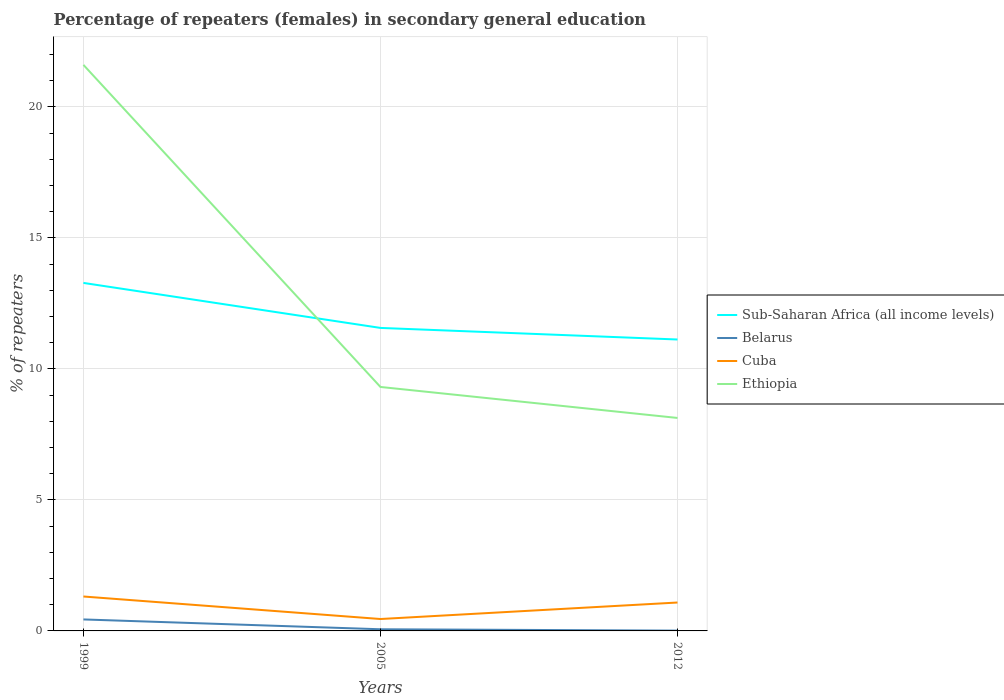How many different coloured lines are there?
Keep it short and to the point. 4. Does the line corresponding to Cuba intersect with the line corresponding to Belarus?
Provide a succinct answer. No. Across all years, what is the maximum percentage of female repeaters in Cuba?
Your answer should be very brief. 0.45. What is the total percentage of female repeaters in Belarus in the graph?
Keep it short and to the point. 0.43. What is the difference between the highest and the second highest percentage of female repeaters in Sub-Saharan Africa (all income levels)?
Provide a short and direct response. 2.16. How many lines are there?
Your response must be concise. 4. How many years are there in the graph?
Provide a short and direct response. 3. Are the values on the major ticks of Y-axis written in scientific E-notation?
Provide a short and direct response. No. Does the graph contain any zero values?
Give a very brief answer. No. Does the graph contain grids?
Give a very brief answer. Yes. Where does the legend appear in the graph?
Provide a short and direct response. Center right. What is the title of the graph?
Offer a terse response. Percentage of repeaters (females) in secondary general education. Does "Cambodia" appear as one of the legend labels in the graph?
Provide a succinct answer. No. What is the label or title of the X-axis?
Provide a succinct answer. Years. What is the label or title of the Y-axis?
Offer a very short reply. % of repeaters. What is the % of repeaters of Sub-Saharan Africa (all income levels) in 1999?
Your answer should be compact. 13.28. What is the % of repeaters of Belarus in 1999?
Offer a very short reply. 0.44. What is the % of repeaters of Cuba in 1999?
Provide a short and direct response. 1.31. What is the % of repeaters of Ethiopia in 1999?
Your answer should be very brief. 21.6. What is the % of repeaters in Sub-Saharan Africa (all income levels) in 2005?
Provide a short and direct response. 11.56. What is the % of repeaters in Belarus in 2005?
Provide a short and direct response. 0.06. What is the % of repeaters in Cuba in 2005?
Provide a succinct answer. 0.45. What is the % of repeaters in Ethiopia in 2005?
Your response must be concise. 9.31. What is the % of repeaters of Sub-Saharan Africa (all income levels) in 2012?
Your answer should be very brief. 11.12. What is the % of repeaters in Belarus in 2012?
Provide a succinct answer. 0.01. What is the % of repeaters of Cuba in 2012?
Provide a short and direct response. 1.08. What is the % of repeaters of Ethiopia in 2012?
Offer a terse response. 8.13. Across all years, what is the maximum % of repeaters in Sub-Saharan Africa (all income levels)?
Keep it short and to the point. 13.28. Across all years, what is the maximum % of repeaters in Belarus?
Make the answer very short. 0.44. Across all years, what is the maximum % of repeaters in Cuba?
Ensure brevity in your answer.  1.31. Across all years, what is the maximum % of repeaters of Ethiopia?
Ensure brevity in your answer.  21.6. Across all years, what is the minimum % of repeaters of Sub-Saharan Africa (all income levels)?
Provide a short and direct response. 11.12. Across all years, what is the minimum % of repeaters in Belarus?
Your answer should be very brief. 0.01. Across all years, what is the minimum % of repeaters of Cuba?
Give a very brief answer. 0.45. Across all years, what is the minimum % of repeaters of Ethiopia?
Give a very brief answer. 8.13. What is the total % of repeaters in Sub-Saharan Africa (all income levels) in the graph?
Keep it short and to the point. 35.96. What is the total % of repeaters of Belarus in the graph?
Provide a succinct answer. 0.51. What is the total % of repeaters in Cuba in the graph?
Provide a short and direct response. 2.85. What is the total % of repeaters of Ethiopia in the graph?
Offer a terse response. 39.04. What is the difference between the % of repeaters in Sub-Saharan Africa (all income levels) in 1999 and that in 2005?
Your answer should be compact. 1.72. What is the difference between the % of repeaters of Belarus in 1999 and that in 2005?
Offer a terse response. 0.37. What is the difference between the % of repeaters in Cuba in 1999 and that in 2005?
Your answer should be very brief. 0.86. What is the difference between the % of repeaters of Ethiopia in 1999 and that in 2005?
Your answer should be very brief. 12.29. What is the difference between the % of repeaters in Sub-Saharan Africa (all income levels) in 1999 and that in 2012?
Offer a terse response. 2.16. What is the difference between the % of repeaters of Belarus in 1999 and that in 2012?
Give a very brief answer. 0.43. What is the difference between the % of repeaters of Cuba in 1999 and that in 2012?
Your response must be concise. 0.23. What is the difference between the % of repeaters in Ethiopia in 1999 and that in 2012?
Your response must be concise. 13.47. What is the difference between the % of repeaters of Sub-Saharan Africa (all income levels) in 2005 and that in 2012?
Offer a terse response. 0.44. What is the difference between the % of repeaters in Belarus in 2005 and that in 2012?
Provide a succinct answer. 0.05. What is the difference between the % of repeaters in Cuba in 2005 and that in 2012?
Provide a succinct answer. -0.63. What is the difference between the % of repeaters in Ethiopia in 2005 and that in 2012?
Offer a terse response. 1.18. What is the difference between the % of repeaters of Sub-Saharan Africa (all income levels) in 1999 and the % of repeaters of Belarus in 2005?
Offer a terse response. 13.22. What is the difference between the % of repeaters in Sub-Saharan Africa (all income levels) in 1999 and the % of repeaters in Cuba in 2005?
Ensure brevity in your answer.  12.83. What is the difference between the % of repeaters of Sub-Saharan Africa (all income levels) in 1999 and the % of repeaters of Ethiopia in 2005?
Your answer should be compact. 3.97. What is the difference between the % of repeaters in Belarus in 1999 and the % of repeaters in Cuba in 2005?
Make the answer very short. -0.02. What is the difference between the % of repeaters in Belarus in 1999 and the % of repeaters in Ethiopia in 2005?
Your response must be concise. -8.87. What is the difference between the % of repeaters in Cuba in 1999 and the % of repeaters in Ethiopia in 2005?
Your answer should be compact. -8. What is the difference between the % of repeaters of Sub-Saharan Africa (all income levels) in 1999 and the % of repeaters of Belarus in 2012?
Make the answer very short. 13.27. What is the difference between the % of repeaters of Sub-Saharan Africa (all income levels) in 1999 and the % of repeaters of Cuba in 2012?
Your response must be concise. 12.2. What is the difference between the % of repeaters in Sub-Saharan Africa (all income levels) in 1999 and the % of repeaters in Ethiopia in 2012?
Offer a terse response. 5.15. What is the difference between the % of repeaters of Belarus in 1999 and the % of repeaters of Cuba in 2012?
Your answer should be compact. -0.65. What is the difference between the % of repeaters of Belarus in 1999 and the % of repeaters of Ethiopia in 2012?
Give a very brief answer. -7.69. What is the difference between the % of repeaters of Cuba in 1999 and the % of repeaters of Ethiopia in 2012?
Ensure brevity in your answer.  -6.81. What is the difference between the % of repeaters in Sub-Saharan Africa (all income levels) in 2005 and the % of repeaters in Belarus in 2012?
Make the answer very short. 11.55. What is the difference between the % of repeaters of Sub-Saharan Africa (all income levels) in 2005 and the % of repeaters of Cuba in 2012?
Offer a terse response. 10.48. What is the difference between the % of repeaters of Sub-Saharan Africa (all income levels) in 2005 and the % of repeaters of Ethiopia in 2012?
Provide a short and direct response. 3.44. What is the difference between the % of repeaters in Belarus in 2005 and the % of repeaters in Cuba in 2012?
Offer a very short reply. -1.02. What is the difference between the % of repeaters of Belarus in 2005 and the % of repeaters of Ethiopia in 2012?
Make the answer very short. -8.06. What is the difference between the % of repeaters of Cuba in 2005 and the % of repeaters of Ethiopia in 2012?
Make the answer very short. -7.67. What is the average % of repeaters in Sub-Saharan Africa (all income levels) per year?
Keep it short and to the point. 11.99. What is the average % of repeaters of Belarus per year?
Your answer should be compact. 0.17. What is the average % of repeaters in Cuba per year?
Offer a very short reply. 0.95. What is the average % of repeaters of Ethiopia per year?
Your answer should be very brief. 13.01. In the year 1999, what is the difference between the % of repeaters in Sub-Saharan Africa (all income levels) and % of repeaters in Belarus?
Provide a short and direct response. 12.84. In the year 1999, what is the difference between the % of repeaters in Sub-Saharan Africa (all income levels) and % of repeaters in Cuba?
Ensure brevity in your answer.  11.97. In the year 1999, what is the difference between the % of repeaters in Sub-Saharan Africa (all income levels) and % of repeaters in Ethiopia?
Provide a short and direct response. -8.32. In the year 1999, what is the difference between the % of repeaters in Belarus and % of repeaters in Cuba?
Your response must be concise. -0.88. In the year 1999, what is the difference between the % of repeaters of Belarus and % of repeaters of Ethiopia?
Your answer should be very brief. -21.16. In the year 1999, what is the difference between the % of repeaters of Cuba and % of repeaters of Ethiopia?
Give a very brief answer. -20.29. In the year 2005, what is the difference between the % of repeaters in Sub-Saharan Africa (all income levels) and % of repeaters in Belarus?
Your response must be concise. 11.5. In the year 2005, what is the difference between the % of repeaters of Sub-Saharan Africa (all income levels) and % of repeaters of Cuba?
Make the answer very short. 11.11. In the year 2005, what is the difference between the % of repeaters in Sub-Saharan Africa (all income levels) and % of repeaters in Ethiopia?
Your answer should be compact. 2.25. In the year 2005, what is the difference between the % of repeaters of Belarus and % of repeaters of Cuba?
Make the answer very short. -0.39. In the year 2005, what is the difference between the % of repeaters in Belarus and % of repeaters in Ethiopia?
Your answer should be compact. -9.25. In the year 2005, what is the difference between the % of repeaters in Cuba and % of repeaters in Ethiopia?
Offer a very short reply. -8.86. In the year 2012, what is the difference between the % of repeaters in Sub-Saharan Africa (all income levels) and % of repeaters in Belarus?
Make the answer very short. 11.11. In the year 2012, what is the difference between the % of repeaters of Sub-Saharan Africa (all income levels) and % of repeaters of Cuba?
Provide a succinct answer. 10.04. In the year 2012, what is the difference between the % of repeaters of Sub-Saharan Africa (all income levels) and % of repeaters of Ethiopia?
Offer a terse response. 2.99. In the year 2012, what is the difference between the % of repeaters in Belarus and % of repeaters in Cuba?
Provide a succinct answer. -1.07. In the year 2012, what is the difference between the % of repeaters of Belarus and % of repeaters of Ethiopia?
Offer a terse response. -8.12. In the year 2012, what is the difference between the % of repeaters of Cuba and % of repeaters of Ethiopia?
Keep it short and to the point. -7.04. What is the ratio of the % of repeaters in Sub-Saharan Africa (all income levels) in 1999 to that in 2005?
Your response must be concise. 1.15. What is the ratio of the % of repeaters in Belarus in 1999 to that in 2005?
Keep it short and to the point. 6.91. What is the ratio of the % of repeaters of Cuba in 1999 to that in 2005?
Your answer should be very brief. 2.89. What is the ratio of the % of repeaters of Ethiopia in 1999 to that in 2005?
Make the answer very short. 2.32. What is the ratio of the % of repeaters of Sub-Saharan Africa (all income levels) in 1999 to that in 2012?
Keep it short and to the point. 1.19. What is the ratio of the % of repeaters in Belarus in 1999 to that in 2012?
Ensure brevity in your answer.  37.54. What is the ratio of the % of repeaters of Cuba in 1999 to that in 2012?
Your response must be concise. 1.21. What is the ratio of the % of repeaters of Ethiopia in 1999 to that in 2012?
Offer a terse response. 2.66. What is the ratio of the % of repeaters of Sub-Saharan Africa (all income levels) in 2005 to that in 2012?
Offer a very short reply. 1.04. What is the ratio of the % of repeaters of Belarus in 2005 to that in 2012?
Your answer should be compact. 5.43. What is the ratio of the % of repeaters of Cuba in 2005 to that in 2012?
Offer a terse response. 0.42. What is the ratio of the % of repeaters in Ethiopia in 2005 to that in 2012?
Your answer should be compact. 1.15. What is the difference between the highest and the second highest % of repeaters in Sub-Saharan Africa (all income levels)?
Make the answer very short. 1.72. What is the difference between the highest and the second highest % of repeaters of Belarus?
Provide a succinct answer. 0.37. What is the difference between the highest and the second highest % of repeaters in Cuba?
Provide a succinct answer. 0.23. What is the difference between the highest and the second highest % of repeaters in Ethiopia?
Keep it short and to the point. 12.29. What is the difference between the highest and the lowest % of repeaters in Sub-Saharan Africa (all income levels)?
Keep it short and to the point. 2.16. What is the difference between the highest and the lowest % of repeaters of Belarus?
Give a very brief answer. 0.43. What is the difference between the highest and the lowest % of repeaters in Cuba?
Give a very brief answer. 0.86. What is the difference between the highest and the lowest % of repeaters of Ethiopia?
Ensure brevity in your answer.  13.47. 